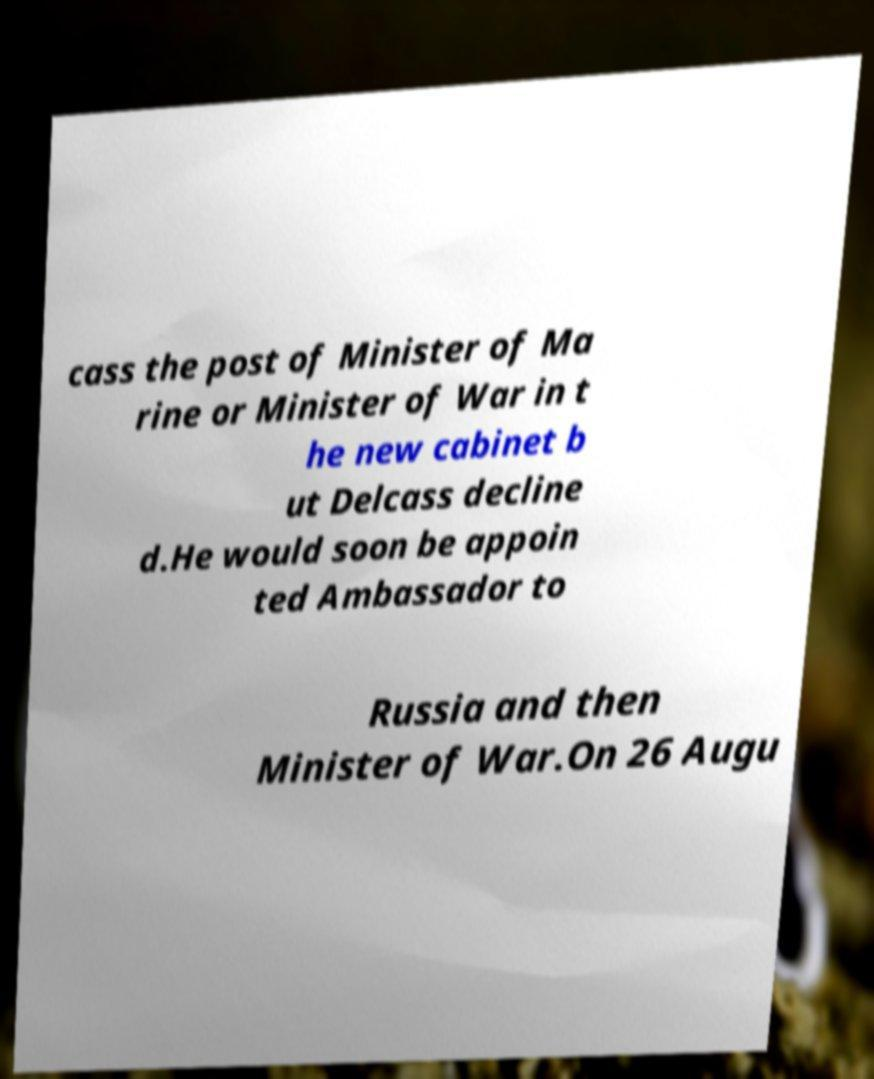Can you accurately transcribe the text from the provided image for me? cass the post of Minister of Ma rine or Minister of War in t he new cabinet b ut Delcass decline d.He would soon be appoin ted Ambassador to Russia and then Minister of War.On 26 Augu 